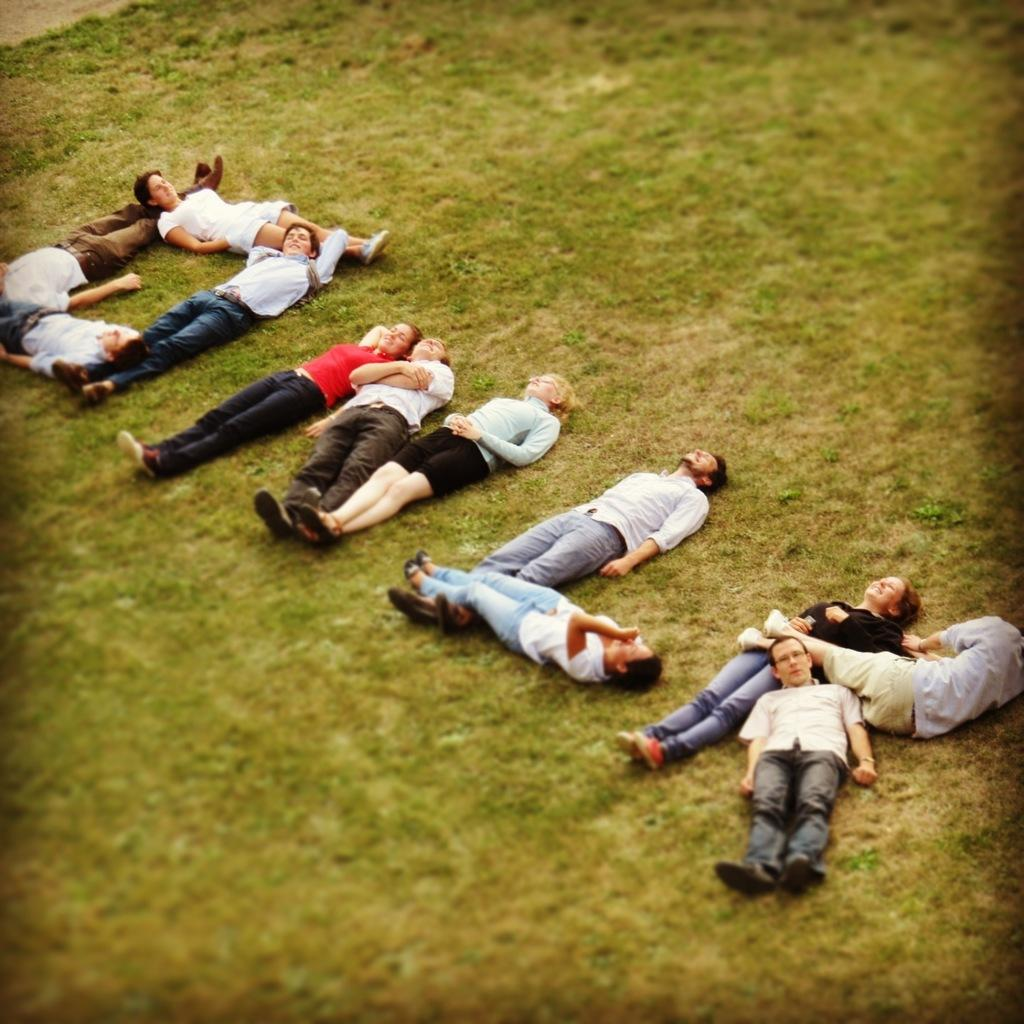How many people are in the image? There are people in the image, but the exact number is not specified. What are the people doing in the image? The people are lying on the ground. What type of drain is visible in the image? There is no drain present in the image. Are the people using quills to write while lying on the ground? There is no mention of quills or writing in the image, and the people are lying on the ground without any visible writing instruments. 